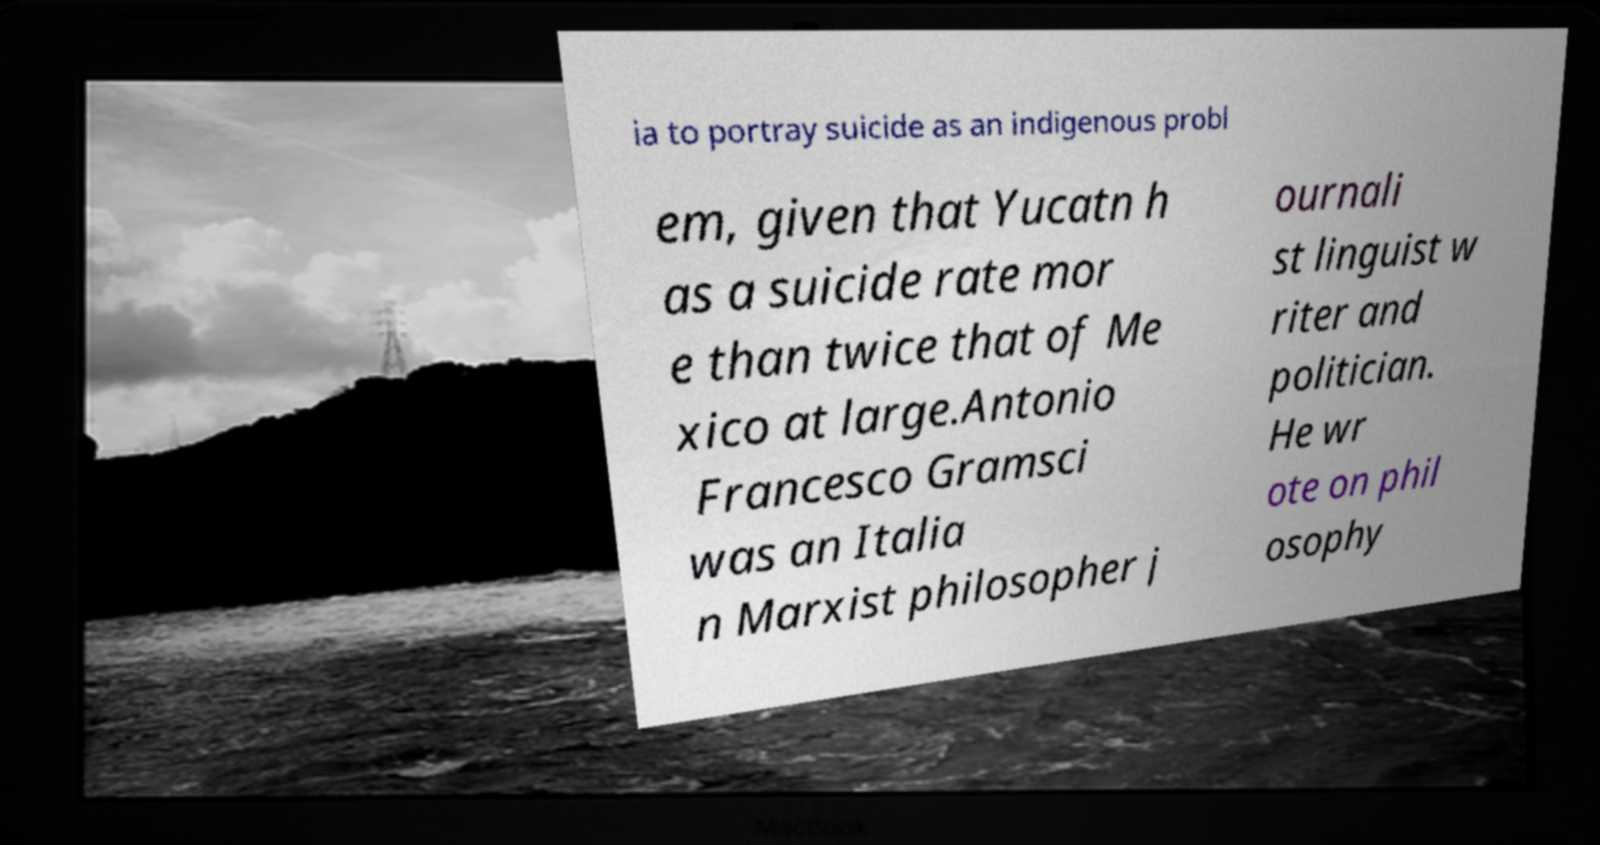Can you accurately transcribe the text from the provided image for me? ia to portray suicide as an indigenous probl em, given that Yucatn h as a suicide rate mor e than twice that of Me xico at large.Antonio Francesco Gramsci was an Italia n Marxist philosopher j ournali st linguist w riter and politician. He wr ote on phil osophy 